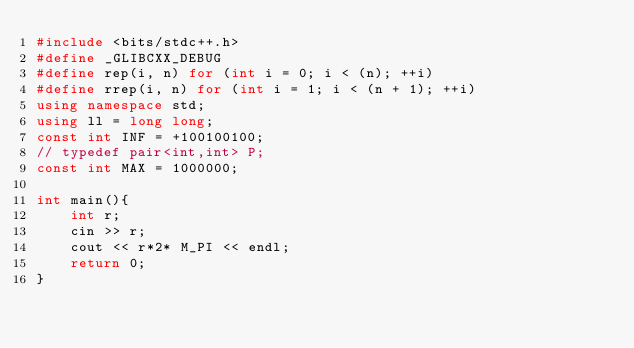<code> <loc_0><loc_0><loc_500><loc_500><_C++_>#include <bits/stdc++.h>
#define _GLIBCXX_DEBUG
#define rep(i, n) for (int i = 0; i < (n); ++i)
#define rrep(i, n) for (int i = 1; i < (n + 1); ++i)
using namespace std;
using ll = long long;
const int INF = +100100100;
// typedef pair<int,int> P;
const int MAX = 1000000;

int main(){
    int r;
    cin >> r;
    cout << r*2* M_PI << endl;
    return 0;
}</code> 